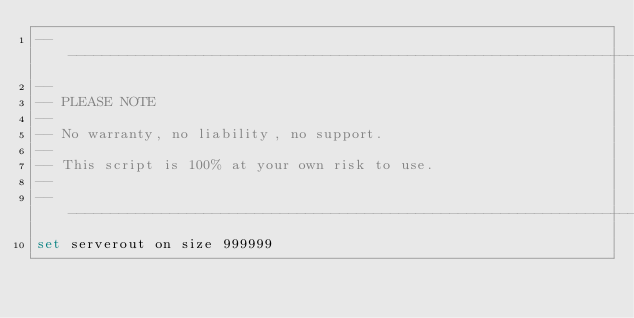<code> <loc_0><loc_0><loc_500><loc_500><_SQL_>-------------------------------------------------------------------------------
--
-- PLEASE NOTE
-- 
-- No warranty, no liability, no support.
--
-- This script is 100% at your own risk to use.
--
-------------------------------------------------------------------------------
set serverout on size 999999
</code> 